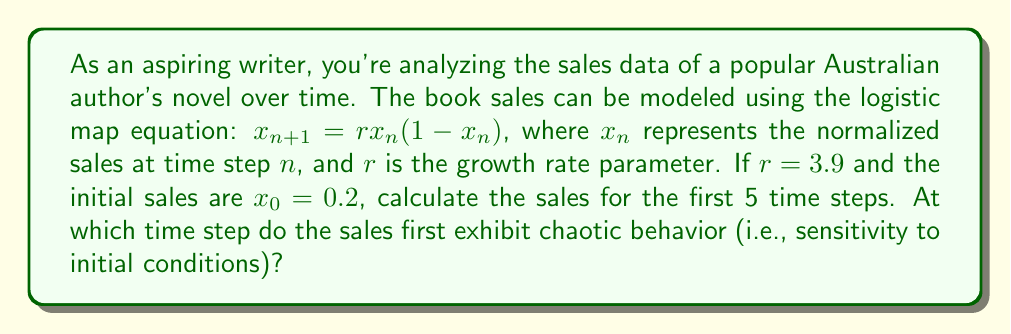Can you solve this math problem? Let's calculate the sales for the first 5 time steps using the logistic map equation:

1) For $n = 0$: $x_0 = 0.2$ (given)

2) For $n = 1$:
   $x_1 = 3.9 \cdot 0.2 \cdot (1-0.2) = 0.624$

3) For $n = 2$:
   $x_2 = 3.9 \cdot 0.624 \cdot (1-0.624) = 0.915384$

4) For $n = 3$:
   $x_3 = 3.9 \cdot 0.915384 \cdot (1-0.915384) = 0.301105$

5) For $n = 4$:
   $x_4 = 3.9 \cdot 0.301105 \cdot (1-0.301105) = 0.820252$

6) For $n = 5$:
   $x_5 = 3.9 \cdot 0.820252 \cdot (1-0.820252) = 0.574614$

To determine when chaotic behavior begins, we need to understand that for $r > 3.57$, the system exhibits chaos. Since $r = 3.9$, the system is in the chaotic regime from the very beginning.

However, to observe sensitivity to initial conditions (a hallmark of chaos), we need to compare this trajectory with one that has a slightly different initial condition. Let's use $x_0 = 0.200001$ and calculate the first few steps:

$x_1 = 0.624001$
$x_2 = 0.915385$
$x_3 = 0.301101$
$x_4 = 0.820256$
$x_5 = 0.574600$

Comparing these values with our original trajectory, we see that by the 3rd iteration ($n = 2$), the values start to diverge noticeably in the third decimal place. This divergence becomes more pronounced in subsequent iterations, indicating sensitivity to initial conditions.
Answer: The sales exhibit chaotic behavior from the 3rd time step (n = 2). 